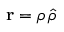<formula> <loc_0><loc_0><loc_500><loc_500>r = \rho \, \hat { \rho }</formula> 